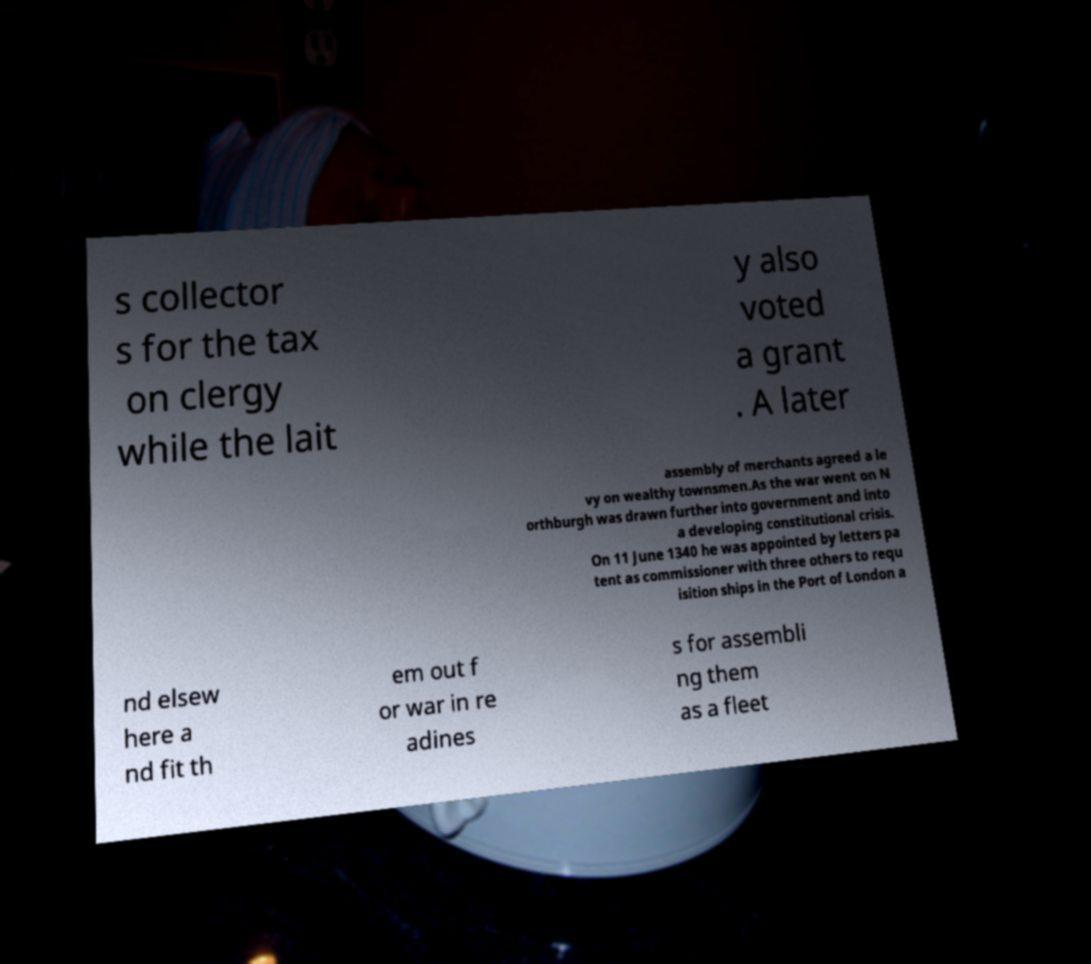There's text embedded in this image that I need extracted. Can you transcribe it verbatim? s collector s for the tax on clergy while the lait y also voted a grant . A later assembly of merchants agreed a le vy on wealthy townsmen.As the war went on N orthburgh was drawn further into government and into a developing constitutional crisis. On 11 June 1340 he was appointed by letters pa tent as commissioner with three others to requ isition ships in the Port of London a nd elsew here a nd fit th em out f or war in re adines s for assembli ng them as a fleet 